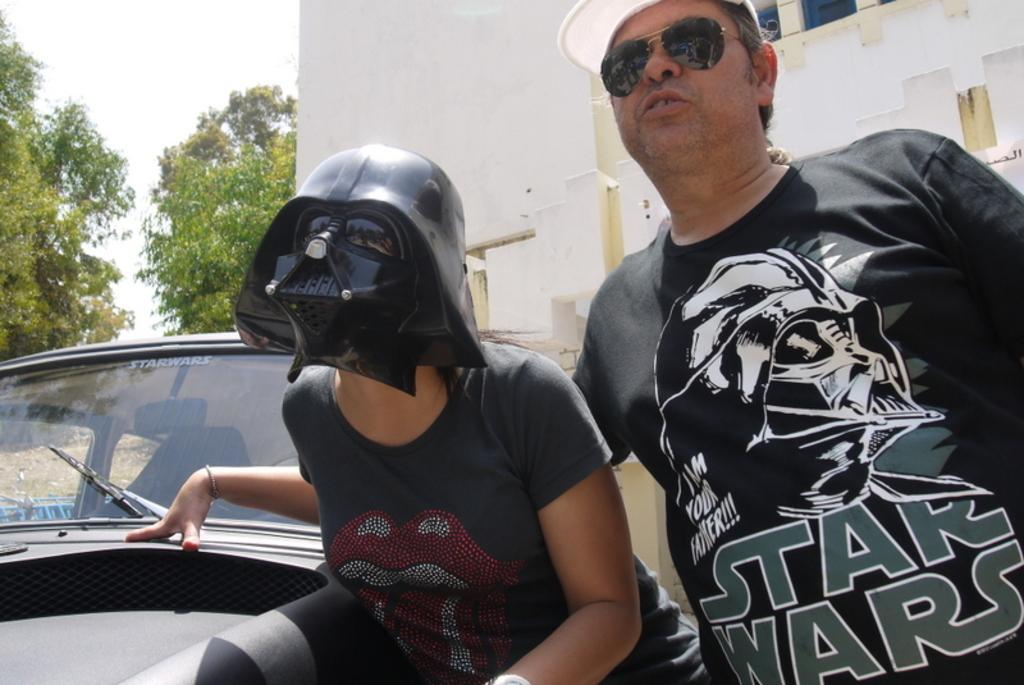How many people are in the image? There are two people in the image. What is one person wearing in the image? One person is wearing a mask. What is located beside the people in the image? There is a car beside the people in the image. What can be seen in the background of the image? There is a building and trees in the background of the image. What type of scissors are being used to cut the jam in the image? There is no jam or scissors present in the image. What team are the people in the image supporting? There is no indication of a team or any sports-related activity in the image. 